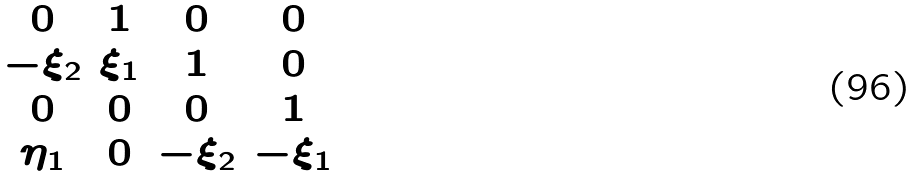Convert formula to latex. <formula><loc_0><loc_0><loc_500><loc_500>\begin{matrix} 0 & 1 & 0 & 0 \\ - \xi _ { 2 } & \xi _ { 1 } & 1 & 0 \\ 0 & 0 & 0 & 1 \\ \eta _ { 1 } & 0 & - \xi _ { 2 } & - \xi _ { 1 } \end{matrix}</formula> 